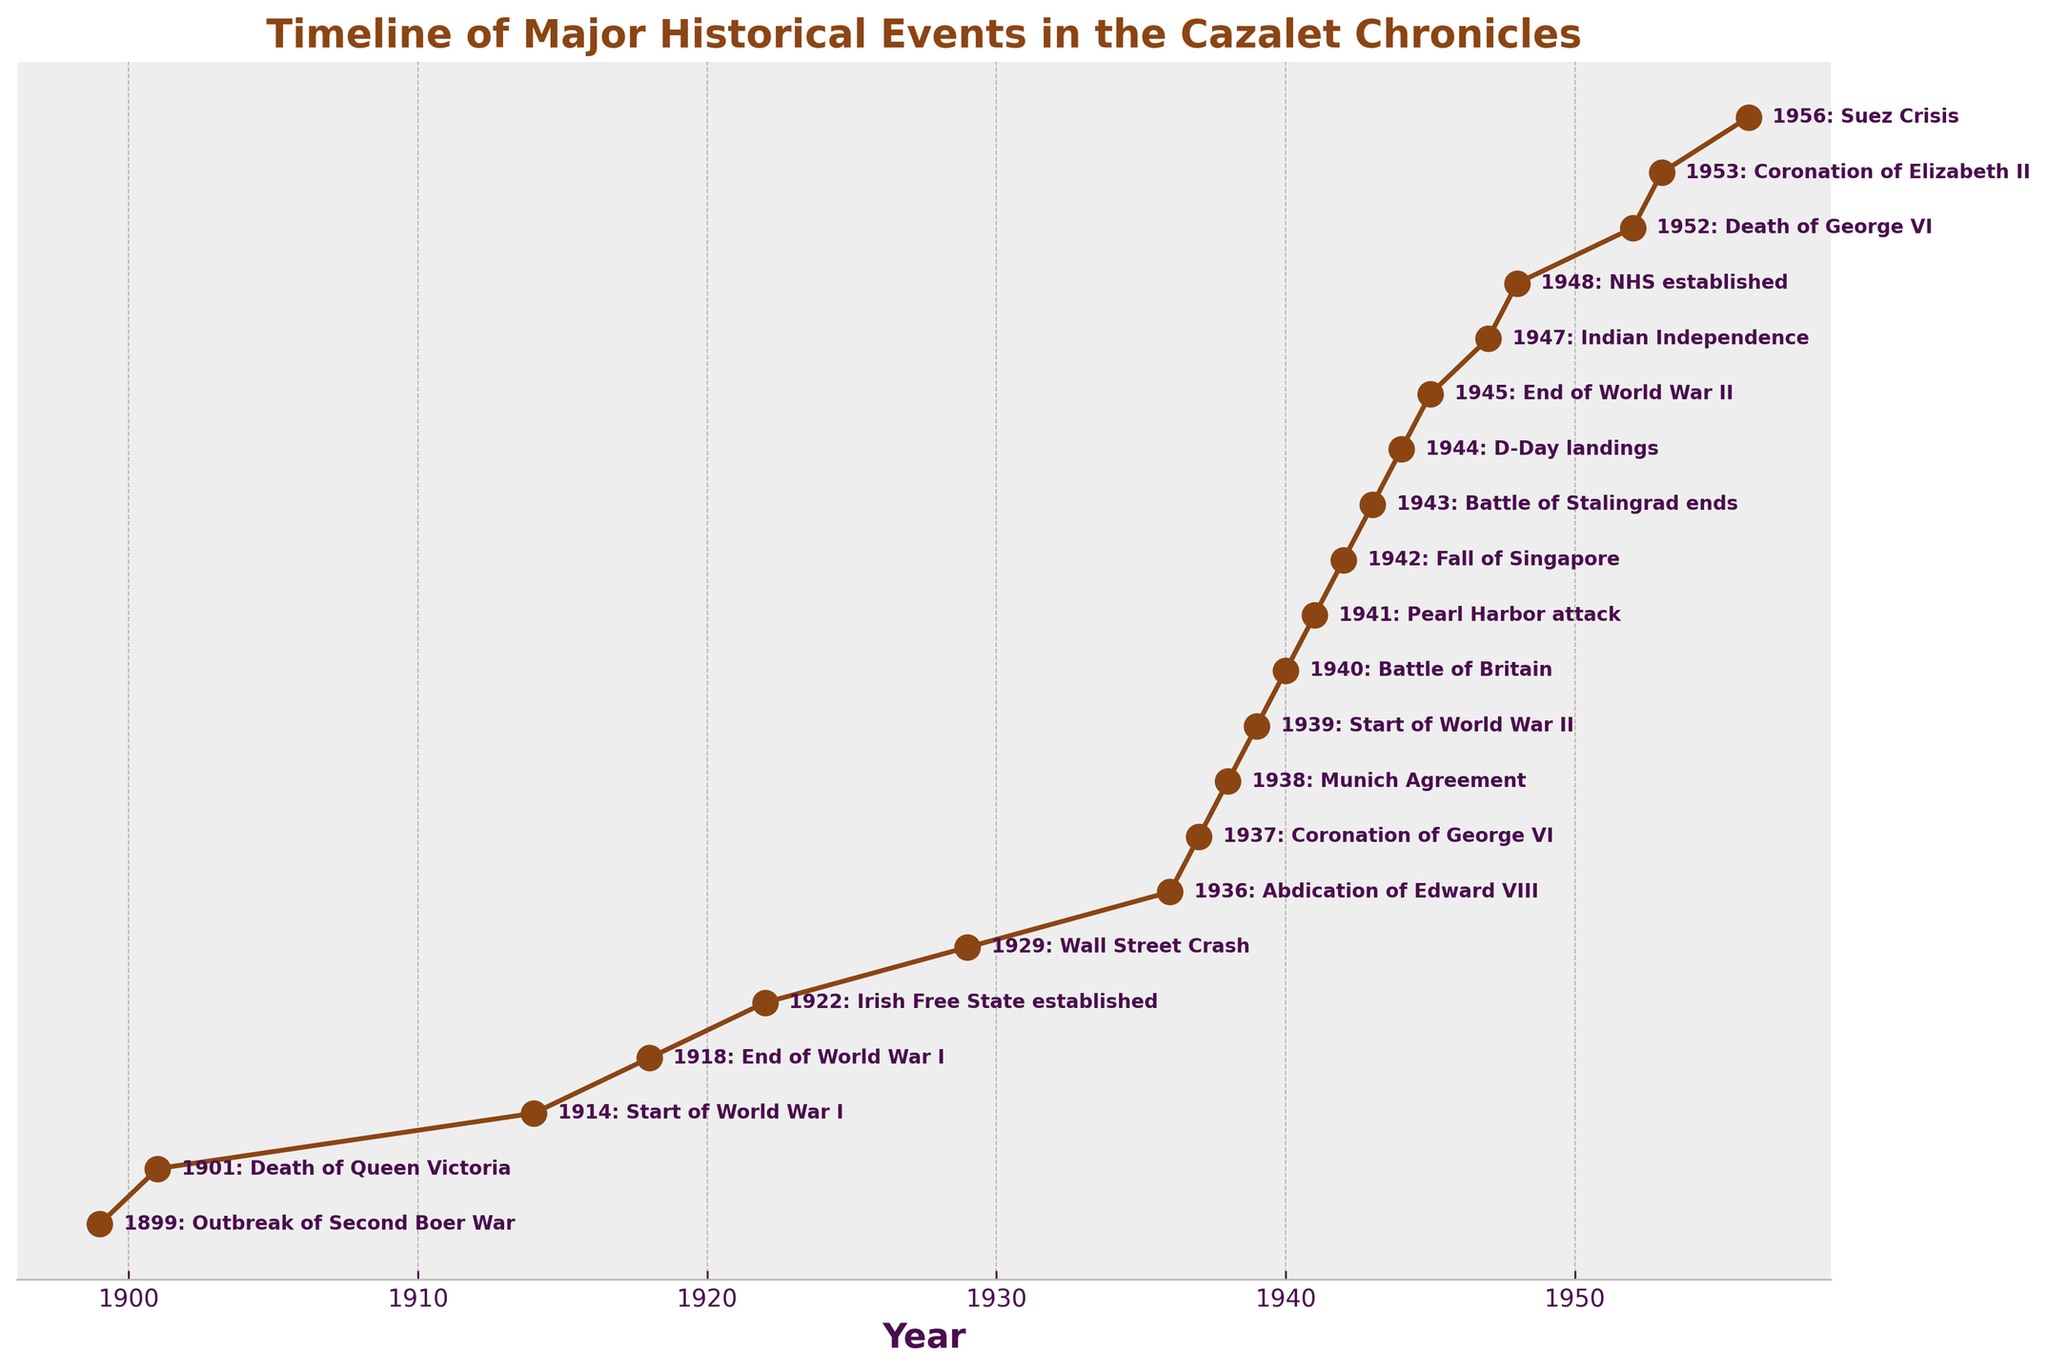What is the earliest event in the timeline? Identify the first entry in the timeline by looking for the earliest year on the x-axis. In this case, the earliest year noted is 1899.
Answer: Outbreak of Second Boer War Which event occurred in the same year as the end of World War II? Locate the year 1945 on the x-axis and read the event annotation for that year. The annotation reads "End of World War II."
Answer: End of World War II What is the span of time between the start of World War I and World War II? Find the years marking the start of World War I (1914) and World War II (1939). Calculate the difference by subtracting the earlier year from the later year: 1939 - 1914 = 25 years.
Answer: 25 years How many years after the end of World War I was the Coronation of George VI? The end of World War I happened in 1918, and the Coronation of George VI was in 1937. Subtract the earlier year from the later year: 1937 - 1918 = 19 years.
Answer: 19 years Which event happened closest to the year 1950? Identify the years near 1950 and observe the corresponding events. The events and their years are: 1948 (NHS established), 1952 (Death of George VI), and 1953 (Coronation of Elizabeth II). The closest event to 1950 is the Death of George VI, occurring in 1952.
Answer: Death of George VI Compare the two events marked in 1936 and 1937. Which year corresponds to the Coronation of George VI? Locate the years 1936 and 1937 on the timeline and read their annotations. In 1936, the event is the Abdication of Edward VIII, and in 1937, it is the Coronation of George VI.
Answer: 1937 What major event is annotated more recently after the End of World War II? Locate the year 1945 (End of World War II) on the x-axis and find the next subsequent year with an event annotation. The next notable event is in 1947, Indian Independence.
Answer: Indian Independence What is the difference in years between the Coronation of Elizabeth II and the establishment of the NHS? Identify the years for the Coronation of Elizabeth II (1953) and the establishment of the NHS (1948). Calculate their difference: 1953 - 1948 = 5 years.
Answer: 5 years What were the two events noted during the 1940s? Identify and list the events that occurred in the 1940s by checking each year in that range. The events are: Battle of Britain (1940), Pearl Harbor attack (1941), Fall of Singapore (1942), Battle of Stalingrad ends (1943), D-Day landings (1944), End of World War II (1945), and Indian Independence (1947). The most noticeable are from 1940 to 1945 but if we strictly limit to 1940s decade: Battle of Britain (1940) and Pearl Harbor attack (1941).
Answer: Battle of Britain, Pearl Harbor attack 